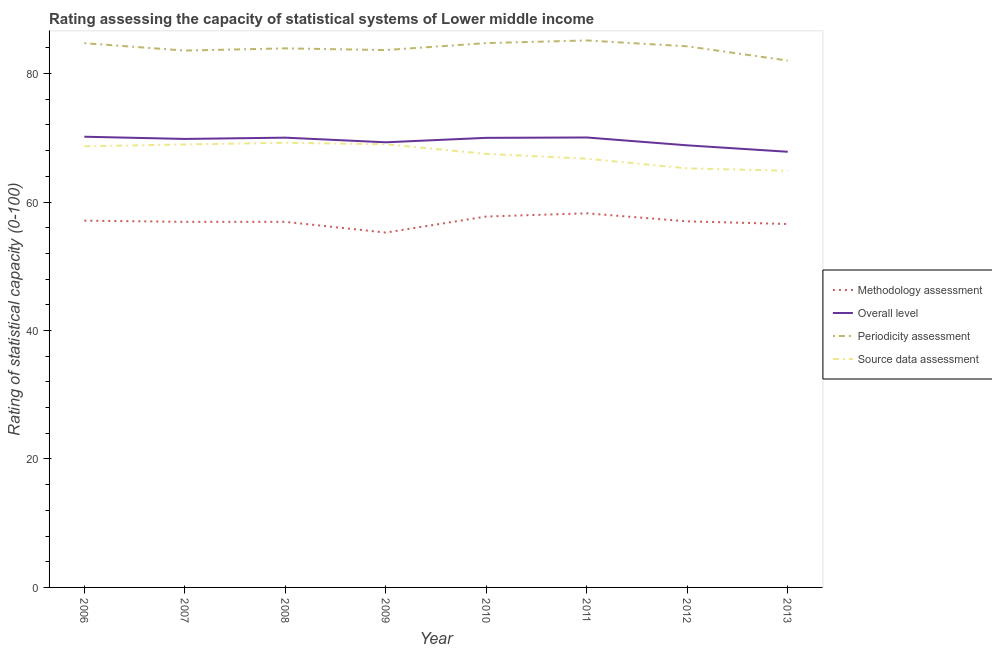How many different coloured lines are there?
Your answer should be compact. 4. Does the line corresponding to methodology assessment rating intersect with the line corresponding to periodicity assessment rating?
Make the answer very short. No. Is the number of lines equal to the number of legend labels?
Make the answer very short. Yes. What is the source data assessment rating in 2012?
Give a very brief answer. 65.25. Across all years, what is the maximum periodicity assessment rating?
Provide a short and direct response. 85.17. Across all years, what is the minimum methodology assessment rating?
Give a very brief answer. 55.25. In which year was the methodology assessment rating maximum?
Offer a very short reply. 2011. What is the total source data assessment rating in the graph?
Provide a succinct answer. 540.27. What is the difference between the periodicity assessment rating in 2007 and that in 2011?
Provide a succinct answer. -1.58. What is the difference between the source data assessment rating in 2009 and the periodicity assessment rating in 2006?
Your answer should be compact. -15.74. What is the average overall level rating per year?
Your answer should be compact. 69.51. In the year 2008, what is the difference between the source data assessment rating and overall level rating?
Keep it short and to the point. -0.8. What is the ratio of the overall level rating in 2007 to that in 2010?
Make the answer very short. 1. What is the difference between the highest and the second highest overall level rating?
Give a very brief answer. 0.12. What is the difference between the highest and the lowest methodology assessment rating?
Your answer should be compact. 3. In how many years, is the periodicity assessment rating greater than the average periodicity assessment rating taken over all years?
Keep it short and to the point. 4. Is it the case that in every year, the sum of the methodology assessment rating and overall level rating is greater than the periodicity assessment rating?
Ensure brevity in your answer.  Yes. Is the source data assessment rating strictly less than the overall level rating over the years?
Keep it short and to the point. Yes. Does the graph contain any zero values?
Your answer should be compact. No. Does the graph contain grids?
Ensure brevity in your answer.  No. How are the legend labels stacked?
Offer a terse response. Vertical. What is the title of the graph?
Make the answer very short. Rating assessing the capacity of statistical systems of Lower middle income. What is the label or title of the X-axis?
Your response must be concise. Year. What is the label or title of the Y-axis?
Offer a terse response. Rating of statistical capacity (0-100). What is the Rating of statistical capacity (0-100) of Methodology assessment in 2006?
Ensure brevity in your answer.  57.11. What is the Rating of statistical capacity (0-100) in Overall level in 2006?
Your answer should be very brief. 70.18. What is the Rating of statistical capacity (0-100) in Periodicity assessment in 2006?
Make the answer very short. 84.74. What is the Rating of statistical capacity (0-100) of Source data assessment in 2006?
Offer a very short reply. 68.68. What is the Rating of statistical capacity (0-100) of Methodology assessment in 2007?
Your response must be concise. 56.92. What is the Rating of statistical capacity (0-100) of Overall level in 2007?
Your answer should be very brief. 69.83. What is the Rating of statistical capacity (0-100) in Periodicity assessment in 2007?
Your answer should be compact. 83.59. What is the Rating of statistical capacity (0-100) in Source data assessment in 2007?
Provide a short and direct response. 68.97. What is the Rating of statistical capacity (0-100) in Methodology assessment in 2008?
Offer a very short reply. 56.92. What is the Rating of statistical capacity (0-100) of Overall level in 2008?
Offer a very short reply. 70.03. What is the Rating of statistical capacity (0-100) in Periodicity assessment in 2008?
Give a very brief answer. 83.93. What is the Rating of statistical capacity (0-100) in Source data assessment in 2008?
Offer a very short reply. 69.23. What is the Rating of statistical capacity (0-100) in Methodology assessment in 2009?
Ensure brevity in your answer.  55.25. What is the Rating of statistical capacity (0-100) of Overall level in 2009?
Ensure brevity in your answer.  69.31. What is the Rating of statistical capacity (0-100) of Periodicity assessment in 2009?
Provide a succinct answer. 83.67. What is the Rating of statistical capacity (0-100) of Source data assessment in 2009?
Offer a very short reply. 69. What is the Rating of statistical capacity (0-100) of Methodology assessment in 2010?
Your answer should be very brief. 57.75. What is the Rating of statistical capacity (0-100) in Overall level in 2010?
Make the answer very short. 70. What is the Rating of statistical capacity (0-100) in Periodicity assessment in 2010?
Your answer should be very brief. 84.75. What is the Rating of statistical capacity (0-100) of Source data assessment in 2010?
Ensure brevity in your answer.  67.5. What is the Rating of statistical capacity (0-100) of Methodology assessment in 2011?
Offer a terse response. 58.25. What is the Rating of statistical capacity (0-100) in Overall level in 2011?
Provide a short and direct response. 70.06. What is the Rating of statistical capacity (0-100) in Periodicity assessment in 2011?
Give a very brief answer. 85.17. What is the Rating of statistical capacity (0-100) in Source data assessment in 2011?
Offer a very short reply. 66.75. What is the Rating of statistical capacity (0-100) of Methodology assessment in 2012?
Offer a terse response. 57. What is the Rating of statistical capacity (0-100) in Overall level in 2012?
Ensure brevity in your answer.  68.83. What is the Rating of statistical capacity (0-100) in Periodicity assessment in 2012?
Provide a short and direct response. 84.25. What is the Rating of statistical capacity (0-100) of Source data assessment in 2012?
Offer a terse response. 65.25. What is the Rating of statistical capacity (0-100) in Methodology assessment in 2013?
Make the answer very short. 56.59. What is the Rating of statistical capacity (0-100) in Overall level in 2013?
Your response must be concise. 67.83. What is the Rating of statistical capacity (0-100) in Periodicity assessment in 2013?
Offer a very short reply. 82.03. What is the Rating of statistical capacity (0-100) of Source data assessment in 2013?
Your answer should be very brief. 64.88. Across all years, what is the maximum Rating of statistical capacity (0-100) in Methodology assessment?
Ensure brevity in your answer.  58.25. Across all years, what is the maximum Rating of statistical capacity (0-100) of Overall level?
Your answer should be compact. 70.18. Across all years, what is the maximum Rating of statistical capacity (0-100) in Periodicity assessment?
Provide a succinct answer. 85.17. Across all years, what is the maximum Rating of statistical capacity (0-100) of Source data assessment?
Your answer should be very brief. 69.23. Across all years, what is the minimum Rating of statistical capacity (0-100) of Methodology assessment?
Your answer should be very brief. 55.25. Across all years, what is the minimum Rating of statistical capacity (0-100) of Overall level?
Ensure brevity in your answer.  67.83. Across all years, what is the minimum Rating of statistical capacity (0-100) in Periodicity assessment?
Offer a terse response. 82.03. Across all years, what is the minimum Rating of statistical capacity (0-100) in Source data assessment?
Ensure brevity in your answer.  64.88. What is the total Rating of statistical capacity (0-100) in Methodology assessment in the graph?
Offer a very short reply. 455.79. What is the total Rating of statistical capacity (0-100) of Overall level in the graph?
Provide a short and direct response. 556.06. What is the total Rating of statistical capacity (0-100) of Periodicity assessment in the graph?
Offer a terse response. 672.12. What is the total Rating of statistical capacity (0-100) in Source data assessment in the graph?
Your answer should be very brief. 540.27. What is the difference between the Rating of statistical capacity (0-100) in Methodology assessment in 2006 and that in 2007?
Give a very brief answer. 0.18. What is the difference between the Rating of statistical capacity (0-100) of Overall level in 2006 and that in 2007?
Offer a very short reply. 0.35. What is the difference between the Rating of statistical capacity (0-100) of Periodicity assessment in 2006 and that in 2007?
Ensure brevity in your answer.  1.15. What is the difference between the Rating of statistical capacity (0-100) in Source data assessment in 2006 and that in 2007?
Ensure brevity in your answer.  -0.29. What is the difference between the Rating of statistical capacity (0-100) in Methodology assessment in 2006 and that in 2008?
Your answer should be very brief. 0.18. What is the difference between the Rating of statistical capacity (0-100) in Overall level in 2006 and that in 2008?
Make the answer very short. 0.15. What is the difference between the Rating of statistical capacity (0-100) of Periodicity assessment in 2006 and that in 2008?
Offer a terse response. 0.81. What is the difference between the Rating of statistical capacity (0-100) in Source data assessment in 2006 and that in 2008?
Keep it short and to the point. -0.55. What is the difference between the Rating of statistical capacity (0-100) in Methodology assessment in 2006 and that in 2009?
Provide a succinct answer. 1.86. What is the difference between the Rating of statistical capacity (0-100) in Overall level in 2006 and that in 2009?
Provide a succinct answer. 0.87. What is the difference between the Rating of statistical capacity (0-100) in Periodicity assessment in 2006 and that in 2009?
Give a very brief answer. 1.07. What is the difference between the Rating of statistical capacity (0-100) in Source data assessment in 2006 and that in 2009?
Offer a very short reply. -0.32. What is the difference between the Rating of statistical capacity (0-100) of Methodology assessment in 2006 and that in 2010?
Your answer should be very brief. -0.64. What is the difference between the Rating of statistical capacity (0-100) in Overall level in 2006 and that in 2010?
Keep it short and to the point. 0.18. What is the difference between the Rating of statistical capacity (0-100) of Periodicity assessment in 2006 and that in 2010?
Give a very brief answer. -0.01. What is the difference between the Rating of statistical capacity (0-100) of Source data assessment in 2006 and that in 2010?
Provide a short and direct response. 1.18. What is the difference between the Rating of statistical capacity (0-100) in Methodology assessment in 2006 and that in 2011?
Give a very brief answer. -1.14. What is the difference between the Rating of statistical capacity (0-100) in Overall level in 2006 and that in 2011?
Make the answer very short. 0.12. What is the difference between the Rating of statistical capacity (0-100) of Periodicity assessment in 2006 and that in 2011?
Make the answer very short. -0.43. What is the difference between the Rating of statistical capacity (0-100) in Source data assessment in 2006 and that in 2011?
Give a very brief answer. 1.93. What is the difference between the Rating of statistical capacity (0-100) of Methodology assessment in 2006 and that in 2012?
Make the answer very short. 0.11. What is the difference between the Rating of statistical capacity (0-100) in Overall level in 2006 and that in 2012?
Make the answer very short. 1.34. What is the difference between the Rating of statistical capacity (0-100) of Periodicity assessment in 2006 and that in 2012?
Offer a terse response. 0.49. What is the difference between the Rating of statistical capacity (0-100) in Source data assessment in 2006 and that in 2012?
Provide a short and direct response. 3.43. What is the difference between the Rating of statistical capacity (0-100) in Methodology assessment in 2006 and that in 2013?
Your answer should be compact. 0.52. What is the difference between the Rating of statistical capacity (0-100) of Overall level in 2006 and that in 2013?
Offer a terse response. 2.34. What is the difference between the Rating of statistical capacity (0-100) in Periodicity assessment in 2006 and that in 2013?
Ensure brevity in your answer.  2.7. What is the difference between the Rating of statistical capacity (0-100) of Source data assessment in 2006 and that in 2013?
Provide a succinct answer. 3.81. What is the difference between the Rating of statistical capacity (0-100) of Methodology assessment in 2007 and that in 2008?
Keep it short and to the point. 0. What is the difference between the Rating of statistical capacity (0-100) of Overall level in 2007 and that in 2008?
Your response must be concise. -0.2. What is the difference between the Rating of statistical capacity (0-100) in Periodicity assessment in 2007 and that in 2008?
Keep it short and to the point. -0.34. What is the difference between the Rating of statistical capacity (0-100) of Source data assessment in 2007 and that in 2008?
Provide a short and direct response. -0.26. What is the difference between the Rating of statistical capacity (0-100) of Methodology assessment in 2007 and that in 2009?
Offer a very short reply. 1.67. What is the difference between the Rating of statistical capacity (0-100) of Overall level in 2007 and that in 2009?
Your answer should be very brief. 0.52. What is the difference between the Rating of statistical capacity (0-100) in Periodicity assessment in 2007 and that in 2009?
Give a very brief answer. -0.08. What is the difference between the Rating of statistical capacity (0-100) of Source data assessment in 2007 and that in 2009?
Provide a succinct answer. -0.03. What is the difference between the Rating of statistical capacity (0-100) of Methodology assessment in 2007 and that in 2010?
Make the answer very short. -0.83. What is the difference between the Rating of statistical capacity (0-100) of Overall level in 2007 and that in 2010?
Keep it short and to the point. -0.17. What is the difference between the Rating of statistical capacity (0-100) of Periodicity assessment in 2007 and that in 2010?
Your response must be concise. -1.16. What is the difference between the Rating of statistical capacity (0-100) in Source data assessment in 2007 and that in 2010?
Offer a terse response. 1.47. What is the difference between the Rating of statistical capacity (0-100) in Methodology assessment in 2007 and that in 2011?
Make the answer very short. -1.33. What is the difference between the Rating of statistical capacity (0-100) of Overall level in 2007 and that in 2011?
Your answer should be compact. -0.23. What is the difference between the Rating of statistical capacity (0-100) of Periodicity assessment in 2007 and that in 2011?
Make the answer very short. -1.58. What is the difference between the Rating of statistical capacity (0-100) of Source data assessment in 2007 and that in 2011?
Your answer should be compact. 2.22. What is the difference between the Rating of statistical capacity (0-100) of Methodology assessment in 2007 and that in 2012?
Give a very brief answer. -0.08. What is the difference between the Rating of statistical capacity (0-100) in Overall level in 2007 and that in 2012?
Offer a terse response. 1. What is the difference between the Rating of statistical capacity (0-100) of Periodicity assessment in 2007 and that in 2012?
Offer a very short reply. -0.66. What is the difference between the Rating of statistical capacity (0-100) of Source data assessment in 2007 and that in 2012?
Offer a very short reply. 3.72. What is the difference between the Rating of statistical capacity (0-100) of Methodology assessment in 2007 and that in 2013?
Provide a succinct answer. 0.34. What is the difference between the Rating of statistical capacity (0-100) of Overall level in 2007 and that in 2013?
Provide a short and direct response. 2. What is the difference between the Rating of statistical capacity (0-100) of Periodicity assessment in 2007 and that in 2013?
Offer a very short reply. 1.56. What is the difference between the Rating of statistical capacity (0-100) of Source data assessment in 2007 and that in 2013?
Keep it short and to the point. 4.1. What is the difference between the Rating of statistical capacity (0-100) of Methodology assessment in 2008 and that in 2009?
Give a very brief answer. 1.67. What is the difference between the Rating of statistical capacity (0-100) in Overall level in 2008 and that in 2009?
Offer a very short reply. 0.72. What is the difference between the Rating of statistical capacity (0-100) of Periodicity assessment in 2008 and that in 2009?
Offer a terse response. 0.27. What is the difference between the Rating of statistical capacity (0-100) of Source data assessment in 2008 and that in 2009?
Give a very brief answer. 0.23. What is the difference between the Rating of statistical capacity (0-100) of Methodology assessment in 2008 and that in 2010?
Provide a short and direct response. -0.83. What is the difference between the Rating of statistical capacity (0-100) in Overall level in 2008 and that in 2010?
Your answer should be compact. 0.03. What is the difference between the Rating of statistical capacity (0-100) of Periodicity assessment in 2008 and that in 2010?
Your answer should be very brief. -0.82. What is the difference between the Rating of statistical capacity (0-100) of Source data assessment in 2008 and that in 2010?
Your answer should be compact. 1.73. What is the difference between the Rating of statistical capacity (0-100) in Methodology assessment in 2008 and that in 2011?
Provide a short and direct response. -1.33. What is the difference between the Rating of statistical capacity (0-100) in Overall level in 2008 and that in 2011?
Provide a succinct answer. -0.03. What is the difference between the Rating of statistical capacity (0-100) of Periodicity assessment in 2008 and that in 2011?
Provide a succinct answer. -1.24. What is the difference between the Rating of statistical capacity (0-100) in Source data assessment in 2008 and that in 2011?
Ensure brevity in your answer.  2.48. What is the difference between the Rating of statistical capacity (0-100) in Methodology assessment in 2008 and that in 2012?
Your answer should be compact. -0.08. What is the difference between the Rating of statistical capacity (0-100) of Overall level in 2008 and that in 2012?
Offer a very short reply. 1.2. What is the difference between the Rating of statistical capacity (0-100) of Periodicity assessment in 2008 and that in 2012?
Your answer should be very brief. -0.32. What is the difference between the Rating of statistical capacity (0-100) in Source data assessment in 2008 and that in 2012?
Ensure brevity in your answer.  3.98. What is the difference between the Rating of statistical capacity (0-100) in Methodology assessment in 2008 and that in 2013?
Ensure brevity in your answer.  0.34. What is the difference between the Rating of statistical capacity (0-100) of Overall level in 2008 and that in 2013?
Offer a terse response. 2.2. What is the difference between the Rating of statistical capacity (0-100) in Periodicity assessment in 2008 and that in 2013?
Provide a short and direct response. 1.9. What is the difference between the Rating of statistical capacity (0-100) of Source data assessment in 2008 and that in 2013?
Provide a short and direct response. 4.35. What is the difference between the Rating of statistical capacity (0-100) in Overall level in 2009 and that in 2010?
Your answer should be compact. -0.69. What is the difference between the Rating of statistical capacity (0-100) of Periodicity assessment in 2009 and that in 2010?
Provide a short and direct response. -1.08. What is the difference between the Rating of statistical capacity (0-100) of Source data assessment in 2009 and that in 2010?
Your answer should be very brief. 1.5. What is the difference between the Rating of statistical capacity (0-100) of Methodology assessment in 2009 and that in 2011?
Your answer should be very brief. -3. What is the difference between the Rating of statistical capacity (0-100) of Overall level in 2009 and that in 2011?
Give a very brief answer. -0.75. What is the difference between the Rating of statistical capacity (0-100) of Periodicity assessment in 2009 and that in 2011?
Ensure brevity in your answer.  -1.5. What is the difference between the Rating of statistical capacity (0-100) in Source data assessment in 2009 and that in 2011?
Make the answer very short. 2.25. What is the difference between the Rating of statistical capacity (0-100) in Methodology assessment in 2009 and that in 2012?
Ensure brevity in your answer.  -1.75. What is the difference between the Rating of statistical capacity (0-100) of Overall level in 2009 and that in 2012?
Offer a very short reply. 0.47. What is the difference between the Rating of statistical capacity (0-100) in Periodicity assessment in 2009 and that in 2012?
Offer a terse response. -0.58. What is the difference between the Rating of statistical capacity (0-100) of Source data assessment in 2009 and that in 2012?
Ensure brevity in your answer.  3.75. What is the difference between the Rating of statistical capacity (0-100) of Methodology assessment in 2009 and that in 2013?
Your response must be concise. -1.34. What is the difference between the Rating of statistical capacity (0-100) in Overall level in 2009 and that in 2013?
Keep it short and to the point. 1.47. What is the difference between the Rating of statistical capacity (0-100) of Periodicity assessment in 2009 and that in 2013?
Your answer should be compact. 1.63. What is the difference between the Rating of statistical capacity (0-100) of Source data assessment in 2009 and that in 2013?
Keep it short and to the point. 4.12. What is the difference between the Rating of statistical capacity (0-100) of Overall level in 2010 and that in 2011?
Keep it short and to the point. -0.06. What is the difference between the Rating of statistical capacity (0-100) of Periodicity assessment in 2010 and that in 2011?
Your response must be concise. -0.42. What is the difference between the Rating of statistical capacity (0-100) of Methodology assessment in 2010 and that in 2012?
Ensure brevity in your answer.  0.75. What is the difference between the Rating of statistical capacity (0-100) of Overall level in 2010 and that in 2012?
Keep it short and to the point. 1.17. What is the difference between the Rating of statistical capacity (0-100) of Periodicity assessment in 2010 and that in 2012?
Your answer should be very brief. 0.5. What is the difference between the Rating of statistical capacity (0-100) in Source data assessment in 2010 and that in 2012?
Provide a succinct answer. 2.25. What is the difference between the Rating of statistical capacity (0-100) of Methodology assessment in 2010 and that in 2013?
Keep it short and to the point. 1.16. What is the difference between the Rating of statistical capacity (0-100) in Overall level in 2010 and that in 2013?
Offer a terse response. 2.17. What is the difference between the Rating of statistical capacity (0-100) of Periodicity assessment in 2010 and that in 2013?
Make the answer very short. 2.72. What is the difference between the Rating of statistical capacity (0-100) in Source data assessment in 2010 and that in 2013?
Keep it short and to the point. 2.62. What is the difference between the Rating of statistical capacity (0-100) of Overall level in 2011 and that in 2012?
Offer a terse response. 1.22. What is the difference between the Rating of statistical capacity (0-100) in Methodology assessment in 2011 and that in 2013?
Ensure brevity in your answer.  1.66. What is the difference between the Rating of statistical capacity (0-100) of Overall level in 2011 and that in 2013?
Keep it short and to the point. 2.22. What is the difference between the Rating of statistical capacity (0-100) in Periodicity assessment in 2011 and that in 2013?
Your answer should be compact. 3.13. What is the difference between the Rating of statistical capacity (0-100) of Source data assessment in 2011 and that in 2013?
Your answer should be compact. 1.87. What is the difference between the Rating of statistical capacity (0-100) in Methodology assessment in 2012 and that in 2013?
Your answer should be very brief. 0.41. What is the difference between the Rating of statistical capacity (0-100) of Periodicity assessment in 2012 and that in 2013?
Your answer should be very brief. 2.22. What is the difference between the Rating of statistical capacity (0-100) in Source data assessment in 2012 and that in 2013?
Offer a very short reply. 0.37. What is the difference between the Rating of statistical capacity (0-100) in Methodology assessment in 2006 and the Rating of statistical capacity (0-100) in Overall level in 2007?
Offer a very short reply. -12.72. What is the difference between the Rating of statistical capacity (0-100) of Methodology assessment in 2006 and the Rating of statistical capacity (0-100) of Periodicity assessment in 2007?
Make the answer very short. -26.48. What is the difference between the Rating of statistical capacity (0-100) of Methodology assessment in 2006 and the Rating of statistical capacity (0-100) of Source data assessment in 2007?
Keep it short and to the point. -11.87. What is the difference between the Rating of statistical capacity (0-100) in Overall level in 2006 and the Rating of statistical capacity (0-100) in Periodicity assessment in 2007?
Provide a short and direct response. -13.41. What is the difference between the Rating of statistical capacity (0-100) of Overall level in 2006 and the Rating of statistical capacity (0-100) of Source data assessment in 2007?
Make the answer very short. 1.2. What is the difference between the Rating of statistical capacity (0-100) of Periodicity assessment in 2006 and the Rating of statistical capacity (0-100) of Source data assessment in 2007?
Keep it short and to the point. 15.76. What is the difference between the Rating of statistical capacity (0-100) in Methodology assessment in 2006 and the Rating of statistical capacity (0-100) in Overall level in 2008?
Keep it short and to the point. -12.92. What is the difference between the Rating of statistical capacity (0-100) of Methodology assessment in 2006 and the Rating of statistical capacity (0-100) of Periodicity assessment in 2008?
Ensure brevity in your answer.  -26.83. What is the difference between the Rating of statistical capacity (0-100) of Methodology assessment in 2006 and the Rating of statistical capacity (0-100) of Source data assessment in 2008?
Your answer should be very brief. -12.13. What is the difference between the Rating of statistical capacity (0-100) of Overall level in 2006 and the Rating of statistical capacity (0-100) of Periodicity assessment in 2008?
Provide a succinct answer. -13.76. What is the difference between the Rating of statistical capacity (0-100) in Overall level in 2006 and the Rating of statistical capacity (0-100) in Source data assessment in 2008?
Offer a terse response. 0.94. What is the difference between the Rating of statistical capacity (0-100) in Periodicity assessment in 2006 and the Rating of statistical capacity (0-100) in Source data assessment in 2008?
Provide a short and direct response. 15.51. What is the difference between the Rating of statistical capacity (0-100) in Methodology assessment in 2006 and the Rating of statistical capacity (0-100) in Overall level in 2009?
Give a very brief answer. -12.2. What is the difference between the Rating of statistical capacity (0-100) of Methodology assessment in 2006 and the Rating of statistical capacity (0-100) of Periodicity assessment in 2009?
Ensure brevity in your answer.  -26.56. What is the difference between the Rating of statistical capacity (0-100) in Methodology assessment in 2006 and the Rating of statistical capacity (0-100) in Source data assessment in 2009?
Offer a terse response. -11.89. What is the difference between the Rating of statistical capacity (0-100) of Overall level in 2006 and the Rating of statistical capacity (0-100) of Periodicity assessment in 2009?
Make the answer very short. -13.49. What is the difference between the Rating of statistical capacity (0-100) in Overall level in 2006 and the Rating of statistical capacity (0-100) in Source data assessment in 2009?
Your answer should be compact. 1.18. What is the difference between the Rating of statistical capacity (0-100) in Periodicity assessment in 2006 and the Rating of statistical capacity (0-100) in Source data assessment in 2009?
Provide a short and direct response. 15.74. What is the difference between the Rating of statistical capacity (0-100) of Methodology assessment in 2006 and the Rating of statistical capacity (0-100) of Overall level in 2010?
Keep it short and to the point. -12.89. What is the difference between the Rating of statistical capacity (0-100) of Methodology assessment in 2006 and the Rating of statistical capacity (0-100) of Periodicity assessment in 2010?
Keep it short and to the point. -27.64. What is the difference between the Rating of statistical capacity (0-100) of Methodology assessment in 2006 and the Rating of statistical capacity (0-100) of Source data assessment in 2010?
Offer a terse response. -10.39. What is the difference between the Rating of statistical capacity (0-100) of Overall level in 2006 and the Rating of statistical capacity (0-100) of Periodicity assessment in 2010?
Your answer should be compact. -14.57. What is the difference between the Rating of statistical capacity (0-100) of Overall level in 2006 and the Rating of statistical capacity (0-100) of Source data assessment in 2010?
Ensure brevity in your answer.  2.68. What is the difference between the Rating of statistical capacity (0-100) in Periodicity assessment in 2006 and the Rating of statistical capacity (0-100) in Source data assessment in 2010?
Your answer should be compact. 17.24. What is the difference between the Rating of statistical capacity (0-100) in Methodology assessment in 2006 and the Rating of statistical capacity (0-100) in Overall level in 2011?
Your response must be concise. -12.95. What is the difference between the Rating of statistical capacity (0-100) of Methodology assessment in 2006 and the Rating of statistical capacity (0-100) of Periodicity assessment in 2011?
Provide a short and direct response. -28.06. What is the difference between the Rating of statistical capacity (0-100) in Methodology assessment in 2006 and the Rating of statistical capacity (0-100) in Source data assessment in 2011?
Make the answer very short. -9.64. What is the difference between the Rating of statistical capacity (0-100) of Overall level in 2006 and the Rating of statistical capacity (0-100) of Periodicity assessment in 2011?
Your answer should be compact. -14.99. What is the difference between the Rating of statistical capacity (0-100) in Overall level in 2006 and the Rating of statistical capacity (0-100) in Source data assessment in 2011?
Provide a short and direct response. 3.43. What is the difference between the Rating of statistical capacity (0-100) of Periodicity assessment in 2006 and the Rating of statistical capacity (0-100) of Source data assessment in 2011?
Your answer should be compact. 17.99. What is the difference between the Rating of statistical capacity (0-100) in Methodology assessment in 2006 and the Rating of statistical capacity (0-100) in Overall level in 2012?
Your answer should be very brief. -11.73. What is the difference between the Rating of statistical capacity (0-100) of Methodology assessment in 2006 and the Rating of statistical capacity (0-100) of Periodicity assessment in 2012?
Provide a succinct answer. -27.14. What is the difference between the Rating of statistical capacity (0-100) in Methodology assessment in 2006 and the Rating of statistical capacity (0-100) in Source data assessment in 2012?
Offer a terse response. -8.14. What is the difference between the Rating of statistical capacity (0-100) of Overall level in 2006 and the Rating of statistical capacity (0-100) of Periodicity assessment in 2012?
Offer a terse response. -14.07. What is the difference between the Rating of statistical capacity (0-100) of Overall level in 2006 and the Rating of statistical capacity (0-100) of Source data assessment in 2012?
Provide a short and direct response. 4.93. What is the difference between the Rating of statistical capacity (0-100) of Periodicity assessment in 2006 and the Rating of statistical capacity (0-100) of Source data assessment in 2012?
Ensure brevity in your answer.  19.49. What is the difference between the Rating of statistical capacity (0-100) of Methodology assessment in 2006 and the Rating of statistical capacity (0-100) of Overall level in 2013?
Your answer should be very brief. -10.73. What is the difference between the Rating of statistical capacity (0-100) in Methodology assessment in 2006 and the Rating of statistical capacity (0-100) in Periodicity assessment in 2013?
Make the answer very short. -24.93. What is the difference between the Rating of statistical capacity (0-100) in Methodology assessment in 2006 and the Rating of statistical capacity (0-100) in Source data assessment in 2013?
Your answer should be very brief. -7.77. What is the difference between the Rating of statistical capacity (0-100) in Overall level in 2006 and the Rating of statistical capacity (0-100) in Periodicity assessment in 2013?
Provide a short and direct response. -11.86. What is the difference between the Rating of statistical capacity (0-100) of Overall level in 2006 and the Rating of statistical capacity (0-100) of Source data assessment in 2013?
Your answer should be compact. 5.3. What is the difference between the Rating of statistical capacity (0-100) of Periodicity assessment in 2006 and the Rating of statistical capacity (0-100) of Source data assessment in 2013?
Offer a very short reply. 19.86. What is the difference between the Rating of statistical capacity (0-100) of Methodology assessment in 2007 and the Rating of statistical capacity (0-100) of Overall level in 2008?
Give a very brief answer. -13.11. What is the difference between the Rating of statistical capacity (0-100) of Methodology assessment in 2007 and the Rating of statistical capacity (0-100) of Periodicity assessment in 2008?
Your response must be concise. -27.01. What is the difference between the Rating of statistical capacity (0-100) of Methodology assessment in 2007 and the Rating of statistical capacity (0-100) of Source data assessment in 2008?
Keep it short and to the point. -12.31. What is the difference between the Rating of statistical capacity (0-100) of Overall level in 2007 and the Rating of statistical capacity (0-100) of Periodicity assessment in 2008?
Make the answer very short. -14.1. What is the difference between the Rating of statistical capacity (0-100) in Overall level in 2007 and the Rating of statistical capacity (0-100) in Source data assessment in 2008?
Offer a very short reply. 0.6. What is the difference between the Rating of statistical capacity (0-100) of Periodicity assessment in 2007 and the Rating of statistical capacity (0-100) of Source data assessment in 2008?
Provide a succinct answer. 14.36. What is the difference between the Rating of statistical capacity (0-100) in Methodology assessment in 2007 and the Rating of statistical capacity (0-100) in Overall level in 2009?
Your answer should be very brief. -12.38. What is the difference between the Rating of statistical capacity (0-100) in Methodology assessment in 2007 and the Rating of statistical capacity (0-100) in Periodicity assessment in 2009?
Provide a short and direct response. -26.74. What is the difference between the Rating of statistical capacity (0-100) in Methodology assessment in 2007 and the Rating of statistical capacity (0-100) in Source data assessment in 2009?
Keep it short and to the point. -12.08. What is the difference between the Rating of statistical capacity (0-100) of Overall level in 2007 and the Rating of statistical capacity (0-100) of Periodicity assessment in 2009?
Keep it short and to the point. -13.84. What is the difference between the Rating of statistical capacity (0-100) in Overall level in 2007 and the Rating of statistical capacity (0-100) in Source data assessment in 2009?
Offer a terse response. 0.83. What is the difference between the Rating of statistical capacity (0-100) in Periodicity assessment in 2007 and the Rating of statistical capacity (0-100) in Source data assessment in 2009?
Offer a terse response. 14.59. What is the difference between the Rating of statistical capacity (0-100) of Methodology assessment in 2007 and the Rating of statistical capacity (0-100) of Overall level in 2010?
Make the answer very short. -13.08. What is the difference between the Rating of statistical capacity (0-100) of Methodology assessment in 2007 and the Rating of statistical capacity (0-100) of Periodicity assessment in 2010?
Ensure brevity in your answer.  -27.83. What is the difference between the Rating of statistical capacity (0-100) of Methodology assessment in 2007 and the Rating of statistical capacity (0-100) of Source data assessment in 2010?
Ensure brevity in your answer.  -10.58. What is the difference between the Rating of statistical capacity (0-100) of Overall level in 2007 and the Rating of statistical capacity (0-100) of Periodicity assessment in 2010?
Make the answer very short. -14.92. What is the difference between the Rating of statistical capacity (0-100) in Overall level in 2007 and the Rating of statistical capacity (0-100) in Source data assessment in 2010?
Make the answer very short. 2.33. What is the difference between the Rating of statistical capacity (0-100) of Periodicity assessment in 2007 and the Rating of statistical capacity (0-100) of Source data assessment in 2010?
Provide a succinct answer. 16.09. What is the difference between the Rating of statistical capacity (0-100) in Methodology assessment in 2007 and the Rating of statistical capacity (0-100) in Overall level in 2011?
Ensure brevity in your answer.  -13.13. What is the difference between the Rating of statistical capacity (0-100) of Methodology assessment in 2007 and the Rating of statistical capacity (0-100) of Periodicity assessment in 2011?
Your response must be concise. -28.24. What is the difference between the Rating of statistical capacity (0-100) of Methodology assessment in 2007 and the Rating of statistical capacity (0-100) of Source data assessment in 2011?
Your response must be concise. -9.83. What is the difference between the Rating of statistical capacity (0-100) in Overall level in 2007 and the Rating of statistical capacity (0-100) in Periodicity assessment in 2011?
Offer a very short reply. -15.34. What is the difference between the Rating of statistical capacity (0-100) of Overall level in 2007 and the Rating of statistical capacity (0-100) of Source data assessment in 2011?
Your answer should be compact. 3.08. What is the difference between the Rating of statistical capacity (0-100) in Periodicity assessment in 2007 and the Rating of statistical capacity (0-100) in Source data assessment in 2011?
Your response must be concise. 16.84. What is the difference between the Rating of statistical capacity (0-100) in Methodology assessment in 2007 and the Rating of statistical capacity (0-100) in Overall level in 2012?
Ensure brevity in your answer.  -11.91. What is the difference between the Rating of statistical capacity (0-100) in Methodology assessment in 2007 and the Rating of statistical capacity (0-100) in Periodicity assessment in 2012?
Give a very brief answer. -27.33. What is the difference between the Rating of statistical capacity (0-100) of Methodology assessment in 2007 and the Rating of statistical capacity (0-100) of Source data assessment in 2012?
Offer a terse response. -8.33. What is the difference between the Rating of statistical capacity (0-100) of Overall level in 2007 and the Rating of statistical capacity (0-100) of Periodicity assessment in 2012?
Your response must be concise. -14.42. What is the difference between the Rating of statistical capacity (0-100) of Overall level in 2007 and the Rating of statistical capacity (0-100) of Source data assessment in 2012?
Your answer should be very brief. 4.58. What is the difference between the Rating of statistical capacity (0-100) in Periodicity assessment in 2007 and the Rating of statistical capacity (0-100) in Source data assessment in 2012?
Your answer should be very brief. 18.34. What is the difference between the Rating of statistical capacity (0-100) of Methodology assessment in 2007 and the Rating of statistical capacity (0-100) of Overall level in 2013?
Offer a terse response. -10.91. What is the difference between the Rating of statistical capacity (0-100) of Methodology assessment in 2007 and the Rating of statistical capacity (0-100) of Periodicity assessment in 2013?
Provide a short and direct response. -25.11. What is the difference between the Rating of statistical capacity (0-100) of Methodology assessment in 2007 and the Rating of statistical capacity (0-100) of Source data assessment in 2013?
Keep it short and to the point. -7.96. What is the difference between the Rating of statistical capacity (0-100) of Overall level in 2007 and the Rating of statistical capacity (0-100) of Periodicity assessment in 2013?
Offer a terse response. -12.2. What is the difference between the Rating of statistical capacity (0-100) of Overall level in 2007 and the Rating of statistical capacity (0-100) of Source data assessment in 2013?
Ensure brevity in your answer.  4.95. What is the difference between the Rating of statistical capacity (0-100) of Periodicity assessment in 2007 and the Rating of statistical capacity (0-100) of Source data assessment in 2013?
Offer a very short reply. 18.71. What is the difference between the Rating of statistical capacity (0-100) of Methodology assessment in 2008 and the Rating of statistical capacity (0-100) of Overall level in 2009?
Your response must be concise. -12.38. What is the difference between the Rating of statistical capacity (0-100) of Methodology assessment in 2008 and the Rating of statistical capacity (0-100) of Periodicity assessment in 2009?
Your response must be concise. -26.74. What is the difference between the Rating of statistical capacity (0-100) of Methodology assessment in 2008 and the Rating of statistical capacity (0-100) of Source data assessment in 2009?
Give a very brief answer. -12.08. What is the difference between the Rating of statistical capacity (0-100) of Overall level in 2008 and the Rating of statistical capacity (0-100) of Periodicity assessment in 2009?
Ensure brevity in your answer.  -13.64. What is the difference between the Rating of statistical capacity (0-100) in Overall level in 2008 and the Rating of statistical capacity (0-100) in Source data assessment in 2009?
Ensure brevity in your answer.  1.03. What is the difference between the Rating of statistical capacity (0-100) in Periodicity assessment in 2008 and the Rating of statistical capacity (0-100) in Source data assessment in 2009?
Provide a succinct answer. 14.93. What is the difference between the Rating of statistical capacity (0-100) in Methodology assessment in 2008 and the Rating of statistical capacity (0-100) in Overall level in 2010?
Ensure brevity in your answer.  -13.08. What is the difference between the Rating of statistical capacity (0-100) in Methodology assessment in 2008 and the Rating of statistical capacity (0-100) in Periodicity assessment in 2010?
Your response must be concise. -27.83. What is the difference between the Rating of statistical capacity (0-100) in Methodology assessment in 2008 and the Rating of statistical capacity (0-100) in Source data assessment in 2010?
Your response must be concise. -10.58. What is the difference between the Rating of statistical capacity (0-100) of Overall level in 2008 and the Rating of statistical capacity (0-100) of Periodicity assessment in 2010?
Your answer should be very brief. -14.72. What is the difference between the Rating of statistical capacity (0-100) of Overall level in 2008 and the Rating of statistical capacity (0-100) of Source data assessment in 2010?
Offer a terse response. 2.53. What is the difference between the Rating of statistical capacity (0-100) in Periodicity assessment in 2008 and the Rating of statistical capacity (0-100) in Source data assessment in 2010?
Keep it short and to the point. 16.43. What is the difference between the Rating of statistical capacity (0-100) of Methodology assessment in 2008 and the Rating of statistical capacity (0-100) of Overall level in 2011?
Provide a succinct answer. -13.13. What is the difference between the Rating of statistical capacity (0-100) in Methodology assessment in 2008 and the Rating of statistical capacity (0-100) in Periodicity assessment in 2011?
Make the answer very short. -28.24. What is the difference between the Rating of statistical capacity (0-100) of Methodology assessment in 2008 and the Rating of statistical capacity (0-100) of Source data assessment in 2011?
Provide a short and direct response. -9.83. What is the difference between the Rating of statistical capacity (0-100) in Overall level in 2008 and the Rating of statistical capacity (0-100) in Periodicity assessment in 2011?
Offer a terse response. -15.14. What is the difference between the Rating of statistical capacity (0-100) in Overall level in 2008 and the Rating of statistical capacity (0-100) in Source data assessment in 2011?
Offer a terse response. 3.28. What is the difference between the Rating of statistical capacity (0-100) in Periodicity assessment in 2008 and the Rating of statistical capacity (0-100) in Source data assessment in 2011?
Your answer should be very brief. 17.18. What is the difference between the Rating of statistical capacity (0-100) of Methodology assessment in 2008 and the Rating of statistical capacity (0-100) of Overall level in 2012?
Provide a short and direct response. -11.91. What is the difference between the Rating of statistical capacity (0-100) of Methodology assessment in 2008 and the Rating of statistical capacity (0-100) of Periodicity assessment in 2012?
Your answer should be compact. -27.33. What is the difference between the Rating of statistical capacity (0-100) of Methodology assessment in 2008 and the Rating of statistical capacity (0-100) of Source data assessment in 2012?
Ensure brevity in your answer.  -8.33. What is the difference between the Rating of statistical capacity (0-100) in Overall level in 2008 and the Rating of statistical capacity (0-100) in Periodicity assessment in 2012?
Your answer should be compact. -14.22. What is the difference between the Rating of statistical capacity (0-100) of Overall level in 2008 and the Rating of statistical capacity (0-100) of Source data assessment in 2012?
Make the answer very short. 4.78. What is the difference between the Rating of statistical capacity (0-100) in Periodicity assessment in 2008 and the Rating of statistical capacity (0-100) in Source data assessment in 2012?
Your answer should be compact. 18.68. What is the difference between the Rating of statistical capacity (0-100) of Methodology assessment in 2008 and the Rating of statistical capacity (0-100) of Overall level in 2013?
Provide a succinct answer. -10.91. What is the difference between the Rating of statistical capacity (0-100) of Methodology assessment in 2008 and the Rating of statistical capacity (0-100) of Periodicity assessment in 2013?
Offer a very short reply. -25.11. What is the difference between the Rating of statistical capacity (0-100) of Methodology assessment in 2008 and the Rating of statistical capacity (0-100) of Source data assessment in 2013?
Offer a very short reply. -7.96. What is the difference between the Rating of statistical capacity (0-100) of Overall level in 2008 and the Rating of statistical capacity (0-100) of Periodicity assessment in 2013?
Your response must be concise. -12. What is the difference between the Rating of statistical capacity (0-100) of Overall level in 2008 and the Rating of statistical capacity (0-100) of Source data assessment in 2013?
Keep it short and to the point. 5.15. What is the difference between the Rating of statistical capacity (0-100) in Periodicity assessment in 2008 and the Rating of statistical capacity (0-100) in Source data assessment in 2013?
Keep it short and to the point. 19.05. What is the difference between the Rating of statistical capacity (0-100) in Methodology assessment in 2009 and the Rating of statistical capacity (0-100) in Overall level in 2010?
Ensure brevity in your answer.  -14.75. What is the difference between the Rating of statistical capacity (0-100) of Methodology assessment in 2009 and the Rating of statistical capacity (0-100) of Periodicity assessment in 2010?
Make the answer very short. -29.5. What is the difference between the Rating of statistical capacity (0-100) in Methodology assessment in 2009 and the Rating of statistical capacity (0-100) in Source data assessment in 2010?
Ensure brevity in your answer.  -12.25. What is the difference between the Rating of statistical capacity (0-100) in Overall level in 2009 and the Rating of statistical capacity (0-100) in Periodicity assessment in 2010?
Your answer should be compact. -15.44. What is the difference between the Rating of statistical capacity (0-100) in Overall level in 2009 and the Rating of statistical capacity (0-100) in Source data assessment in 2010?
Your response must be concise. 1.81. What is the difference between the Rating of statistical capacity (0-100) of Periodicity assessment in 2009 and the Rating of statistical capacity (0-100) of Source data assessment in 2010?
Ensure brevity in your answer.  16.17. What is the difference between the Rating of statistical capacity (0-100) of Methodology assessment in 2009 and the Rating of statistical capacity (0-100) of Overall level in 2011?
Offer a terse response. -14.81. What is the difference between the Rating of statistical capacity (0-100) in Methodology assessment in 2009 and the Rating of statistical capacity (0-100) in Periodicity assessment in 2011?
Offer a terse response. -29.92. What is the difference between the Rating of statistical capacity (0-100) of Overall level in 2009 and the Rating of statistical capacity (0-100) of Periodicity assessment in 2011?
Ensure brevity in your answer.  -15.86. What is the difference between the Rating of statistical capacity (0-100) in Overall level in 2009 and the Rating of statistical capacity (0-100) in Source data assessment in 2011?
Your answer should be very brief. 2.56. What is the difference between the Rating of statistical capacity (0-100) of Periodicity assessment in 2009 and the Rating of statistical capacity (0-100) of Source data assessment in 2011?
Offer a very short reply. 16.92. What is the difference between the Rating of statistical capacity (0-100) in Methodology assessment in 2009 and the Rating of statistical capacity (0-100) in Overall level in 2012?
Offer a terse response. -13.58. What is the difference between the Rating of statistical capacity (0-100) in Overall level in 2009 and the Rating of statistical capacity (0-100) in Periodicity assessment in 2012?
Give a very brief answer. -14.94. What is the difference between the Rating of statistical capacity (0-100) in Overall level in 2009 and the Rating of statistical capacity (0-100) in Source data assessment in 2012?
Your response must be concise. 4.06. What is the difference between the Rating of statistical capacity (0-100) of Periodicity assessment in 2009 and the Rating of statistical capacity (0-100) of Source data assessment in 2012?
Give a very brief answer. 18.42. What is the difference between the Rating of statistical capacity (0-100) in Methodology assessment in 2009 and the Rating of statistical capacity (0-100) in Overall level in 2013?
Ensure brevity in your answer.  -12.58. What is the difference between the Rating of statistical capacity (0-100) in Methodology assessment in 2009 and the Rating of statistical capacity (0-100) in Periodicity assessment in 2013?
Ensure brevity in your answer.  -26.78. What is the difference between the Rating of statistical capacity (0-100) in Methodology assessment in 2009 and the Rating of statistical capacity (0-100) in Source data assessment in 2013?
Provide a succinct answer. -9.63. What is the difference between the Rating of statistical capacity (0-100) in Overall level in 2009 and the Rating of statistical capacity (0-100) in Periodicity assessment in 2013?
Your answer should be very brief. -12.73. What is the difference between the Rating of statistical capacity (0-100) in Overall level in 2009 and the Rating of statistical capacity (0-100) in Source data assessment in 2013?
Keep it short and to the point. 4.43. What is the difference between the Rating of statistical capacity (0-100) of Periodicity assessment in 2009 and the Rating of statistical capacity (0-100) of Source data assessment in 2013?
Give a very brief answer. 18.79. What is the difference between the Rating of statistical capacity (0-100) of Methodology assessment in 2010 and the Rating of statistical capacity (0-100) of Overall level in 2011?
Give a very brief answer. -12.31. What is the difference between the Rating of statistical capacity (0-100) in Methodology assessment in 2010 and the Rating of statistical capacity (0-100) in Periodicity assessment in 2011?
Ensure brevity in your answer.  -27.42. What is the difference between the Rating of statistical capacity (0-100) in Methodology assessment in 2010 and the Rating of statistical capacity (0-100) in Source data assessment in 2011?
Offer a terse response. -9. What is the difference between the Rating of statistical capacity (0-100) in Overall level in 2010 and the Rating of statistical capacity (0-100) in Periodicity assessment in 2011?
Make the answer very short. -15.17. What is the difference between the Rating of statistical capacity (0-100) of Methodology assessment in 2010 and the Rating of statistical capacity (0-100) of Overall level in 2012?
Keep it short and to the point. -11.08. What is the difference between the Rating of statistical capacity (0-100) in Methodology assessment in 2010 and the Rating of statistical capacity (0-100) in Periodicity assessment in 2012?
Keep it short and to the point. -26.5. What is the difference between the Rating of statistical capacity (0-100) in Methodology assessment in 2010 and the Rating of statistical capacity (0-100) in Source data assessment in 2012?
Provide a succinct answer. -7.5. What is the difference between the Rating of statistical capacity (0-100) of Overall level in 2010 and the Rating of statistical capacity (0-100) of Periodicity assessment in 2012?
Your answer should be very brief. -14.25. What is the difference between the Rating of statistical capacity (0-100) in Overall level in 2010 and the Rating of statistical capacity (0-100) in Source data assessment in 2012?
Offer a very short reply. 4.75. What is the difference between the Rating of statistical capacity (0-100) of Methodology assessment in 2010 and the Rating of statistical capacity (0-100) of Overall level in 2013?
Your answer should be very brief. -10.08. What is the difference between the Rating of statistical capacity (0-100) in Methodology assessment in 2010 and the Rating of statistical capacity (0-100) in Periodicity assessment in 2013?
Provide a succinct answer. -24.28. What is the difference between the Rating of statistical capacity (0-100) in Methodology assessment in 2010 and the Rating of statistical capacity (0-100) in Source data assessment in 2013?
Offer a terse response. -7.13. What is the difference between the Rating of statistical capacity (0-100) in Overall level in 2010 and the Rating of statistical capacity (0-100) in Periodicity assessment in 2013?
Your response must be concise. -12.03. What is the difference between the Rating of statistical capacity (0-100) in Overall level in 2010 and the Rating of statistical capacity (0-100) in Source data assessment in 2013?
Provide a succinct answer. 5.12. What is the difference between the Rating of statistical capacity (0-100) in Periodicity assessment in 2010 and the Rating of statistical capacity (0-100) in Source data assessment in 2013?
Offer a terse response. 19.87. What is the difference between the Rating of statistical capacity (0-100) of Methodology assessment in 2011 and the Rating of statistical capacity (0-100) of Overall level in 2012?
Provide a succinct answer. -10.58. What is the difference between the Rating of statistical capacity (0-100) of Methodology assessment in 2011 and the Rating of statistical capacity (0-100) of Source data assessment in 2012?
Provide a short and direct response. -7. What is the difference between the Rating of statistical capacity (0-100) of Overall level in 2011 and the Rating of statistical capacity (0-100) of Periodicity assessment in 2012?
Give a very brief answer. -14.19. What is the difference between the Rating of statistical capacity (0-100) of Overall level in 2011 and the Rating of statistical capacity (0-100) of Source data assessment in 2012?
Your answer should be compact. 4.81. What is the difference between the Rating of statistical capacity (0-100) of Periodicity assessment in 2011 and the Rating of statistical capacity (0-100) of Source data assessment in 2012?
Your response must be concise. 19.92. What is the difference between the Rating of statistical capacity (0-100) in Methodology assessment in 2011 and the Rating of statistical capacity (0-100) in Overall level in 2013?
Offer a very short reply. -9.58. What is the difference between the Rating of statistical capacity (0-100) of Methodology assessment in 2011 and the Rating of statistical capacity (0-100) of Periodicity assessment in 2013?
Provide a short and direct response. -23.78. What is the difference between the Rating of statistical capacity (0-100) in Methodology assessment in 2011 and the Rating of statistical capacity (0-100) in Source data assessment in 2013?
Provide a succinct answer. -6.63. What is the difference between the Rating of statistical capacity (0-100) of Overall level in 2011 and the Rating of statistical capacity (0-100) of Periodicity assessment in 2013?
Ensure brevity in your answer.  -11.98. What is the difference between the Rating of statistical capacity (0-100) of Overall level in 2011 and the Rating of statistical capacity (0-100) of Source data assessment in 2013?
Ensure brevity in your answer.  5.18. What is the difference between the Rating of statistical capacity (0-100) in Periodicity assessment in 2011 and the Rating of statistical capacity (0-100) in Source data assessment in 2013?
Your response must be concise. 20.29. What is the difference between the Rating of statistical capacity (0-100) of Methodology assessment in 2012 and the Rating of statistical capacity (0-100) of Overall level in 2013?
Ensure brevity in your answer.  -10.83. What is the difference between the Rating of statistical capacity (0-100) in Methodology assessment in 2012 and the Rating of statistical capacity (0-100) in Periodicity assessment in 2013?
Make the answer very short. -25.03. What is the difference between the Rating of statistical capacity (0-100) of Methodology assessment in 2012 and the Rating of statistical capacity (0-100) of Source data assessment in 2013?
Provide a short and direct response. -7.88. What is the difference between the Rating of statistical capacity (0-100) of Overall level in 2012 and the Rating of statistical capacity (0-100) of Periodicity assessment in 2013?
Offer a very short reply. -13.2. What is the difference between the Rating of statistical capacity (0-100) in Overall level in 2012 and the Rating of statistical capacity (0-100) in Source data assessment in 2013?
Offer a terse response. 3.96. What is the difference between the Rating of statistical capacity (0-100) in Periodicity assessment in 2012 and the Rating of statistical capacity (0-100) in Source data assessment in 2013?
Provide a short and direct response. 19.37. What is the average Rating of statistical capacity (0-100) of Methodology assessment per year?
Offer a terse response. 56.97. What is the average Rating of statistical capacity (0-100) of Overall level per year?
Offer a terse response. 69.51. What is the average Rating of statistical capacity (0-100) in Periodicity assessment per year?
Your answer should be compact. 84.02. What is the average Rating of statistical capacity (0-100) of Source data assessment per year?
Keep it short and to the point. 67.53. In the year 2006, what is the difference between the Rating of statistical capacity (0-100) of Methodology assessment and Rating of statistical capacity (0-100) of Overall level?
Give a very brief answer. -13.07. In the year 2006, what is the difference between the Rating of statistical capacity (0-100) in Methodology assessment and Rating of statistical capacity (0-100) in Periodicity assessment?
Ensure brevity in your answer.  -27.63. In the year 2006, what is the difference between the Rating of statistical capacity (0-100) in Methodology assessment and Rating of statistical capacity (0-100) in Source data assessment?
Make the answer very short. -11.58. In the year 2006, what is the difference between the Rating of statistical capacity (0-100) of Overall level and Rating of statistical capacity (0-100) of Periodicity assessment?
Make the answer very short. -14.56. In the year 2006, what is the difference between the Rating of statistical capacity (0-100) of Overall level and Rating of statistical capacity (0-100) of Source data assessment?
Your answer should be compact. 1.49. In the year 2006, what is the difference between the Rating of statistical capacity (0-100) in Periodicity assessment and Rating of statistical capacity (0-100) in Source data assessment?
Offer a terse response. 16.05. In the year 2007, what is the difference between the Rating of statistical capacity (0-100) in Methodology assessment and Rating of statistical capacity (0-100) in Overall level?
Ensure brevity in your answer.  -12.91. In the year 2007, what is the difference between the Rating of statistical capacity (0-100) of Methodology assessment and Rating of statistical capacity (0-100) of Periodicity assessment?
Make the answer very short. -26.67. In the year 2007, what is the difference between the Rating of statistical capacity (0-100) of Methodology assessment and Rating of statistical capacity (0-100) of Source data assessment?
Your answer should be compact. -12.05. In the year 2007, what is the difference between the Rating of statistical capacity (0-100) of Overall level and Rating of statistical capacity (0-100) of Periodicity assessment?
Ensure brevity in your answer.  -13.76. In the year 2007, what is the difference between the Rating of statistical capacity (0-100) of Overall level and Rating of statistical capacity (0-100) of Source data assessment?
Keep it short and to the point. 0.85. In the year 2007, what is the difference between the Rating of statistical capacity (0-100) in Periodicity assessment and Rating of statistical capacity (0-100) in Source data assessment?
Your response must be concise. 14.62. In the year 2008, what is the difference between the Rating of statistical capacity (0-100) in Methodology assessment and Rating of statistical capacity (0-100) in Overall level?
Your answer should be compact. -13.11. In the year 2008, what is the difference between the Rating of statistical capacity (0-100) in Methodology assessment and Rating of statistical capacity (0-100) in Periodicity assessment?
Provide a succinct answer. -27.01. In the year 2008, what is the difference between the Rating of statistical capacity (0-100) of Methodology assessment and Rating of statistical capacity (0-100) of Source data assessment?
Your response must be concise. -12.31. In the year 2008, what is the difference between the Rating of statistical capacity (0-100) of Overall level and Rating of statistical capacity (0-100) of Periodicity assessment?
Keep it short and to the point. -13.9. In the year 2008, what is the difference between the Rating of statistical capacity (0-100) in Overall level and Rating of statistical capacity (0-100) in Source data assessment?
Your answer should be compact. 0.8. In the year 2008, what is the difference between the Rating of statistical capacity (0-100) of Periodicity assessment and Rating of statistical capacity (0-100) of Source data assessment?
Keep it short and to the point. 14.7. In the year 2009, what is the difference between the Rating of statistical capacity (0-100) of Methodology assessment and Rating of statistical capacity (0-100) of Overall level?
Ensure brevity in your answer.  -14.06. In the year 2009, what is the difference between the Rating of statistical capacity (0-100) of Methodology assessment and Rating of statistical capacity (0-100) of Periodicity assessment?
Your answer should be compact. -28.42. In the year 2009, what is the difference between the Rating of statistical capacity (0-100) in Methodology assessment and Rating of statistical capacity (0-100) in Source data assessment?
Make the answer very short. -13.75. In the year 2009, what is the difference between the Rating of statistical capacity (0-100) of Overall level and Rating of statistical capacity (0-100) of Periodicity assessment?
Keep it short and to the point. -14.36. In the year 2009, what is the difference between the Rating of statistical capacity (0-100) in Overall level and Rating of statistical capacity (0-100) in Source data assessment?
Provide a short and direct response. 0.31. In the year 2009, what is the difference between the Rating of statistical capacity (0-100) of Periodicity assessment and Rating of statistical capacity (0-100) of Source data assessment?
Your answer should be very brief. 14.67. In the year 2010, what is the difference between the Rating of statistical capacity (0-100) in Methodology assessment and Rating of statistical capacity (0-100) in Overall level?
Provide a short and direct response. -12.25. In the year 2010, what is the difference between the Rating of statistical capacity (0-100) in Methodology assessment and Rating of statistical capacity (0-100) in Periodicity assessment?
Offer a terse response. -27. In the year 2010, what is the difference between the Rating of statistical capacity (0-100) of Methodology assessment and Rating of statistical capacity (0-100) of Source data assessment?
Provide a short and direct response. -9.75. In the year 2010, what is the difference between the Rating of statistical capacity (0-100) of Overall level and Rating of statistical capacity (0-100) of Periodicity assessment?
Give a very brief answer. -14.75. In the year 2010, what is the difference between the Rating of statistical capacity (0-100) of Overall level and Rating of statistical capacity (0-100) of Source data assessment?
Ensure brevity in your answer.  2.5. In the year 2010, what is the difference between the Rating of statistical capacity (0-100) in Periodicity assessment and Rating of statistical capacity (0-100) in Source data assessment?
Keep it short and to the point. 17.25. In the year 2011, what is the difference between the Rating of statistical capacity (0-100) of Methodology assessment and Rating of statistical capacity (0-100) of Overall level?
Offer a very short reply. -11.81. In the year 2011, what is the difference between the Rating of statistical capacity (0-100) of Methodology assessment and Rating of statistical capacity (0-100) of Periodicity assessment?
Make the answer very short. -26.92. In the year 2011, what is the difference between the Rating of statistical capacity (0-100) of Overall level and Rating of statistical capacity (0-100) of Periodicity assessment?
Provide a succinct answer. -15.11. In the year 2011, what is the difference between the Rating of statistical capacity (0-100) in Overall level and Rating of statistical capacity (0-100) in Source data assessment?
Your answer should be compact. 3.31. In the year 2011, what is the difference between the Rating of statistical capacity (0-100) in Periodicity assessment and Rating of statistical capacity (0-100) in Source data assessment?
Provide a short and direct response. 18.42. In the year 2012, what is the difference between the Rating of statistical capacity (0-100) in Methodology assessment and Rating of statistical capacity (0-100) in Overall level?
Your answer should be compact. -11.83. In the year 2012, what is the difference between the Rating of statistical capacity (0-100) of Methodology assessment and Rating of statistical capacity (0-100) of Periodicity assessment?
Make the answer very short. -27.25. In the year 2012, what is the difference between the Rating of statistical capacity (0-100) of Methodology assessment and Rating of statistical capacity (0-100) of Source data assessment?
Offer a terse response. -8.25. In the year 2012, what is the difference between the Rating of statistical capacity (0-100) of Overall level and Rating of statistical capacity (0-100) of Periodicity assessment?
Make the answer very short. -15.42. In the year 2012, what is the difference between the Rating of statistical capacity (0-100) of Overall level and Rating of statistical capacity (0-100) of Source data assessment?
Make the answer very short. 3.58. In the year 2012, what is the difference between the Rating of statistical capacity (0-100) of Periodicity assessment and Rating of statistical capacity (0-100) of Source data assessment?
Provide a succinct answer. 19. In the year 2013, what is the difference between the Rating of statistical capacity (0-100) of Methodology assessment and Rating of statistical capacity (0-100) of Overall level?
Offer a terse response. -11.25. In the year 2013, what is the difference between the Rating of statistical capacity (0-100) in Methodology assessment and Rating of statistical capacity (0-100) in Periodicity assessment?
Ensure brevity in your answer.  -25.45. In the year 2013, what is the difference between the Rating of statistical capacity (0-100) of Methodology assessment and Rating of statistical capacity (0-100) of Source data assessment?
Offer a very short reply. -8.29. In the year 2013, what is the difference between the Rating of statistical capacity (0-100) in Overall level and Rating of statistical capacity (0-100) in Periodicity assessment?
Provide a short and direct response. -14.2. In the year 2013, what is the difference between the Rating of statistical capacity (0-100) in Overall level and Rating of statistical capacity (0-100) in Source data assessment?
Ensure brevity in your answer.  2.95. In the year 2013, what is the difference between the Rating of statistical capacity (0-100) in Periodicity assessment and Rating of statistical capacity (0-100) in Source data assessment?
Your response must be concise. 17.15. What is the ratio of the Rating of statistical capacity (0-100) of Methodology assessment in 2006 to that in 2007?
Offer a terse response. 1. What is the ratio of the Rating of statistical capacity (0-100) in Periodicity assessment in 2006 to that in 2007?
Provide a short and direct response. 1.01. What is the ratio of the Rating of statistical capacity (0-100) of Periodicity assessment in 2006 to that in 2008?
Ensure brevity in your answer.  1.01. What is the ratio of the Rating of statistical capacity (0-100) in Methodology assessment in 2006 to that in 2009?
Provide a succinct answer. 1.03. What is the ratio of the Rating of statistical capacity (0-100) of Overall level in 2006 to that in 2009?
Your answer should be very brief. 1.01. What is the ratio of the Rating of statistical capacity (0-100) of Periodicity assessment in 2006 to that in 2009?
Your response must be concise. 1.01. What is the ratio of the Rating of statistical capacity (0-100) of Methodology assessment in 2006 to that in 2010?
Give a very brief answer. 0.99. What is the ratio of the Rating of statistical capacity (0-100) of Source data assessment in 2006 to that in 2010?
Give a very brief answer. 1.02. What is the ratio of the Rating of statistical capacity (0-100) in Methodology assessment in 2006 to that in 2011?
Provide a short and direct response. 0.98. What is the ratio of the Rating of statistical capacity (0-100) of Periodicity assessment in 2006 to that in 2011?
Your response must be concise. 0.99. What is the ratio of the Rating of statistical capacity (0-100) of Overall level in 2006 to that in 2012?
Your answer should be very brief. 1.02. What is the ratio of the Rating of statistical capacity (0-100) in Periodicity assessment in 2006 to that in 2012?
Keep it short and to the point. 1.01. What is the ratio of the Rating of statistical capacity (0-100) of Source data assessment in 2006 to that in 2012?
Provide a succinct answer. 1.05. What is the ratio of the Rating of statistical capacity (0-100) in Methodology assessment in 2006 to that in 2013?
Provide a succinct answer. 1.01. What is the ratio of the Rating of statistical capacity (0-100) in Overall level in 2006 to that in 2013?
Provide a succinct answer. 1.03. What is the ratio of the Rating of statistical capacity (0-100) in Periodicity assessment in 2006 to that in 2013?
Offer a terse response. 1.03. What is the ratio of the Rating of statistical capacity (0-100) in Source data assessment in 2006 to that in 2013?
Keep it short and to the point. 1.06. What is the ratio of the Rating of statistical capacity (0-100) in Methodology assessment in 2007 to that in 2008?
Your response must be concise. 1. What is the ratio of the Rating of statistical capacity (0-100) of Overall level in 2007 to that in 2008?
Your answer should be very brief. 1. What is the ratio of the Rating of statistical capacity (0-100) in Periodicity assessment in 2007 to that in 2008?
Provide a succinct answer. 1. What is the ratio of the Rating of statistical capacity (0-100) of Source data assessment in 2007 to that in 2008?
Offer a terse response. 1. What is the ratio of the Rating of statistical capacity (0-100) of Methodology assessment in 2007 to that in 2009?
Make the answer very short. 1.03. What is the ratio of the Rating of statistical capacity (0-100) in Overall level in 2007 to that in 2009?
Your response must be concise. 1.01. What is the ratio of the Rating of statistical capacity (0-100) in Periodicity assessment in 2007 to that in 2009?
Provide a succinct answer. 1. What is the ratio of the Rating of statistical capacity (0-100) of Source data assessment in 2007 to that in 2009?
Your answer should be compact. 1. What is the ratio of the Rating of statistical capacity (0-100) of Methodology assessment in 2007 to that in 2010?
Provide a succinct answer. 0.99. What is the ratio of the Rating of statistical capacity (0-100) in Periodicity assessment in 2007 to that in 2010?
Ensure brevity in your answer.  0.99. What is the ratio of the Rating of statistical capacity (0-100) in Source data assessment in 2007 to that in 2010?
Provide a succinct answer. 1.02. What is the ratio of the Rating of statistical capacity (0-100) of Methodology assessment in 2007 to that in 2011?
Ensure brevity in your answer.  0.98. What is the ratio of the Rating of statistical capacity (0-100) in Periodicity assessment in 2007 to that in 2011?
Make the answer very short. 0.98. What is the ratio of the Rating of statistical capacity (0-100) in Methodology assessment in 2007 to that in 2012?
Make the answer very short. 1. What is the ratio of the Rating of statistical capacity (0-100) of Overall level in 2007 to that in 2012?
Your answer should be very brief. 1.01. What is the ratio of the Rating of statistical capacity (0-100) of Periodicity assessment in 2007 to that in 2012?
Give a very brief answer. 0.99. What is the ratio of the Rating of statistical capacity (0-100) in Source data assessment in 2007 to that in 2012?
Offer a terse response. 1.06. What is the ratio of the Rating of statistical capacity (0-100) in Methodology assessment in 2007 to that in 2013?
Your answer should be very brief. 1.01. What is the ratio of the Rating of statistical capacity (0-100) in Overall level in 2007 to that in 2013?
Keep it short and to the point. 1.03. What is the ratio of the Rating of statistical capacity (0-100) in Source data assessment in 2007 to that in 2013?
Keep it short and to the point. 1.06. What is the ratio of the Rating of statistical capacity (0-100) in Methodology assessment in 2008 to that in 2009?
Make the answer very short. 1.03. What is the ratio of the Rating of statistical capacity (0-100) of Overall level in 2008 to that in 2009?
Ensure brevity in your answer.  1.01. What is the ratio of the Rating of statistical capacity (0-100) of Periodicity assessment in 2008 to that in 2009?
Your response must be concise. 1. What is the ratio of the Rating of statistical capacity (0-100) in Methodology assessment in 2008 to that in 2010?
Your answer should be compact. 0.99. What is the ratio of the Rating of statistical capacity (0-100) in Periodicity assessment in 2008 to that in 2010?
Offer a very short reply. 0.99. What is the ratio of the Rating of statistical capacity (0-100) of Source data assessment in 2008 to that in 2010?
Your response must be concise. 1.03. What is the ratio of the Rating of statistical capacity (0-100) of Methodology assessment in 2008 to that in 2011?
Offer a very short reply. 0.98. What is the ratio of the Rating of statistical capacity (0-100) of Periodicity assessment in 2008 to that in 2011?
Make the answer very short. 0.99. What is the ratio of the Rating of statistical capacity (0-100) in Source data assessment in 2008 to that in 2011?
Your answer should be compact. 1.04. What is the ratio of the Rating of statistical capacity (0-100) of Methodology assessment in 2008 to that in 2012?
Your response must be concise. 1. What is the ratio of the Rating of statistical capacity (0-100) in Overall level in 2008 to that in 2012?
Offer a very short reply. 1.02. What is the ratio of the Rating of statistical capacity (0-100) in Source data assessment in 2008 to that in 2012?
Provide a short and direct response. 1.06. What is the ratio of the Rating of statistical capacity (0-100) of Methodology assessment in 2008 to that in 2013?
Your response must be concise. 1.01. What is the ratio of the Rating of statistical capacity (0-100) in Overall level in 2008 to that in 2013?
Your response must be concise. 1.03. What is the ratio of the Rating of statistical capacity (0-100) in Periodicity assessment in 2008 to that in 2013?
Give a very brief answer. 1.02. What is the ratio of the Rating of statistical capacity (0-100) in Source data assessment in 2008 to that in 2013?
Provide a succinct answer. 1.07. What is the ratio of the Rating of statistical capacity (0-100) in Methodology assessment in 2009 to that in 2010?
Ensure brevity in your answer.  0.96. What is the ratio of the Rating of statistical capacity (0-100) in Periodicity assessment in 2009 to that in 2010?
Provide a short and direct response. 0.99. What is the ratio of the Rating of statistical capacity (0-100) in Source data assessment in 2009 to that in 2010?
Keep it short and to the point. 1.02. What is the ratio of the Rating of statistical capacity (0-100) of Methodology assessment in 2009 to that in 2011?
Offer a terse response. 0.95. What is the ratio of the Rating of statistical capacity (0-100) of Overall level in 2009 to that in 2011?
Give a very brief answer. 0.99. What is the ratio of the Rating of statistical capacity (0-100) of Periodicity assessment in 2009 to that in 2011?
Provide a succinct answer. 0.98. What is the ratio of the Rating of statistical capacity (0-100) of Source data assessment in 2009 to that in 2011?
Ensure brevity in your answer.  1.03. What is the ratio of the Rating of statistical capacity (0-100) of Methodology assessment in 2009 to that in 2012?
Provide a succinct answer. 0.97. What is the ratio of the Rating of statistical capacity (0-100) of Source data assessment in 2009 to that in 2012?
Your answer should be very brief. 1.06. What is the ratio of the Rating of statistical capacity (0-100) of Methodology assessment in 2009 to that in 2013?
Your answer should be very brief. 0.98. What is the ratio of the Rating of statistical capacity (0-100) of Overall level in 2009 to that in 2013?
Offer a very short reply. 1.02. What is the ratio of the Rating of statistical capacity (0-100) in Periodicity assessment in 2009 to that in 2013?
Make the answer very short. 1.02. What is the ratio of the Rating of statistical capacity (0-100) in Source data assessment in 2009 to that in 2013?
Make the answer very short. 1.06. What is the ratio of the Rating of statistical capacity (0-100) in Methodology assessment in 2010 to that in 2011?
Ensure brevity in your answer.  0.99. What is the ratio of the Rating of statistical capacity (0-100) in Overall level in 2010 to that in 2011?
Ensure brevity in your answer.  1. What is the ratio of the Rating of statistical capacity (0-100) in Source data assessment in 2010 to that in 2011?
Ensure brevity in your answer.  1.01. What is the ratio of the Rating of statistical capacity (0-100) of Methodology assessment in 2010 to that in 2012?
Offer a terse response. 1.01. What is the ratio of the Rating of statistical capacity (0-100) in Overall level in 2010 to that in 2012?
Give a very brief answer. 1.02. What is the ratio of the Rating of statistical capacity (0-100) in Periodicity assessment in 2010 to that in 2012?
Your response must be concise. 1.01. What is the ratio of the Rating of statistical capacity (0-100) in Source data assessment in 2010 to that in 2012?
Your answer should be compact. 1.03. What is the ratio of the Rating of statistical capacity (0-100) of Methodology assessment in 2010 to that in 2013?
Keep it short and to the point. 1.02. What is the ratio of the Rating of statistical capacity (0-100) of Overall level in 2010 to that in 2013?
Keep it short and to the point. 1.03. What is the ratio of the Rating of statistical capacity (0-100) of Periodicity assessment in 2010 to that in 2013?
Your response must be concise. 1.03. What is the ratio of the Rating of statistical capacity (0-100) in Source data assessment in 2010 to that in 2013?
Your response must be concise. 1.04. What is the ratio of the Rating of statistical capacity (0-100) of Methodology assessment in 2011 to that in 2012?
Your answer should be very brief. 1.02. What is the ratio of the Rating of statistical capacity (0-100) in Overall level in 2011 to that in 2012?
Make the answer very short. 1.02. What is the ratio of the Rating of statistical capacity (0-100) of Periodicity assessment in 2011 to that in 2012?
Your answer should be very brief. 1.01. What is the ratio of the Rating of statistical capacity (0-100) of Methodology assessment in 2011 to that in 2013?
Your response must be concise. 1.03. What is the ratio of the Rating of statistical capacity (0-100) of Overall level in 2011 to that in 2013?
Provide a short and direct response. 1.03. What is the ratio of the Rating of statistical capacity (0-100) of Periodicity assessment in 2011 to that in 2013?
Make the answer very short. 1.04. What is the ratio of the Rating of statistical capacity (0-100) of Source data assessment in 2011 to that in 2013?
Offer a very short reply. 1.03. What is the ratio of the Rating of statistical capacity (0-100) of Methodology assessment in 2012 to that in 2013?
Your response must be concise. 1.01. What is the ratio of the Rating of statistical capacity (0-100) in Overall level in 2012 to that in 2013?
Give a very brief answer. 1.01. What is the ratio of the Rating of statistical capacity (0-100) of Source data assessment in 2012 to that in 2013?
Provide a succinct answer. 1.01. What is the difference between the highest and the second highest Rating of statistical capacity (0-100) of Methodology assessment?
Give a very brief answer. 0.5. What is the difference between the highest and the second highest Rating of statistical capacity (0-100) in Overall level?
Offer a terse response. 0.12. What is the difference between the highest and the second highest Rating of statistical capacity (0-100) of Periodicity assessment?
Offer a terse response. 0.42. What is the difference between the highest and the second highest Rating of statistical capacity (0-100) in Source data assessment?
Offer a terse response. 0.23. What is the difference between the highest and the lowest Rating of statistical capacity (0-100) of Overall level?
Provide a succinct answer. 2.34. What is the difference between the highest and the lowest Rating of statistical capacity (0-100) of Periodicity assessment?
Keep it short and to the point. 3.13. What is the difference between the highest and the lowest Rating of statistical capacity (0-100) in Source data assessment?
Provide a short and direct response. 4.35. 